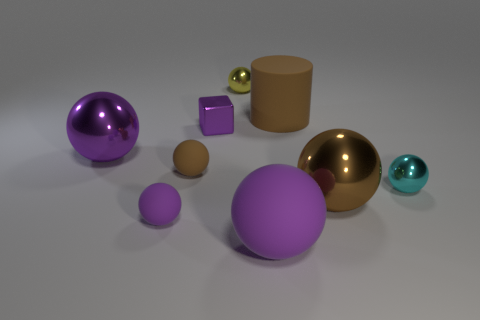The large rubber object that is behind the tiny rubber ball that is behind the small cyan object is what color?
Provide a short and direct response. Brown. What size is the purple ball that is behind the tiny object that is right of the big brown ball?
Make the answer very short. Large. What size is the block that is the same color as the large matte sphere?
Your answer should be very brief. Small. What number of other things are there of the same size as the purple shiny block?
Offer a very short reply. 4. What is the color of the large object that is on the left side of the purple matte ball that is right of the yellow object that is behind the small purple block?
Ensure brevity in your answer.  Purple. What number of other objects are there of the same shape as the small brown object?
Keep it short and to the point. 6. What is the shape of the purple matte thing to the right of the tiny yellow ball?
Make the answer very short. Sphere. Is there a big matte cylinder left of the brown rubber object behind the tiny purple shiny object?
Your answer should be compact. No. The tiny ball that is both right of the cube and in front of the tiny purple cube is what color?
Keep it short and to the point. Cyan. There is a big metallic sphere that is right of the brown ball behind the cyan ball; are there any yellow shiny objects in front of it?
Offer a very short reply. No. 